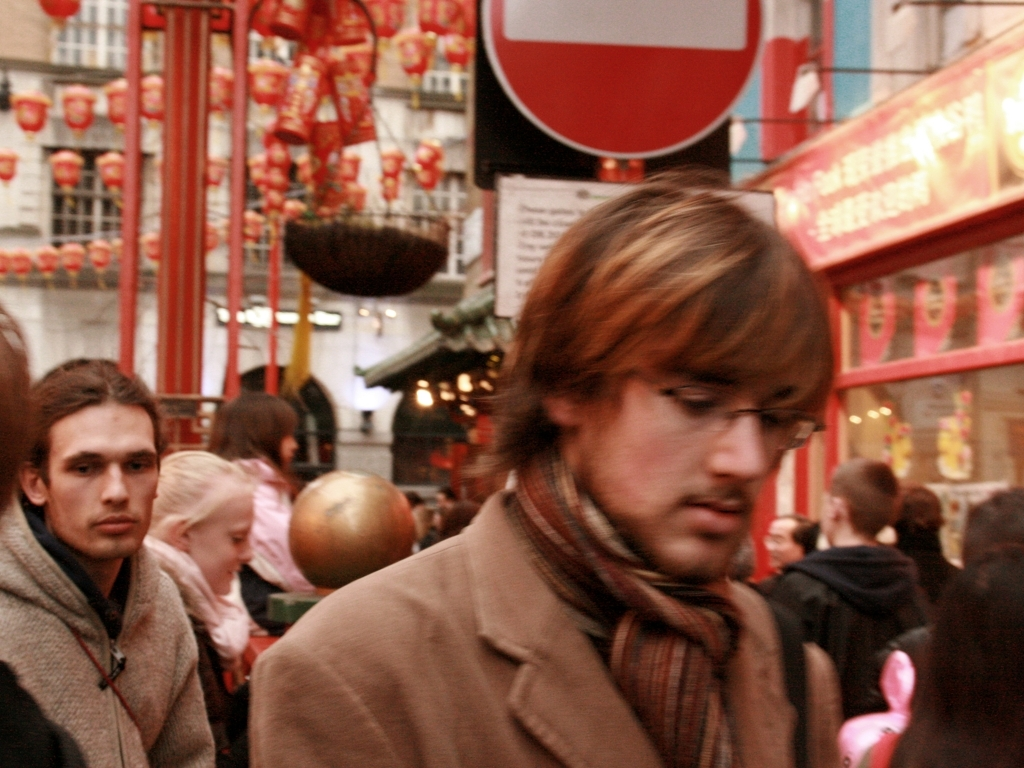What can you tell me about the people in the photograph? The photograph captures a candid moment in a bustling urban setting, possibly a market or a cultural festival due to the presence of red lanterns and banners in the background. The individuals pictured are diverse in age and attire, which suggests a public, communal space. The expressions range from contemplative to preoccupied, indicating a variety of personal experiences and engagements with the environment. 